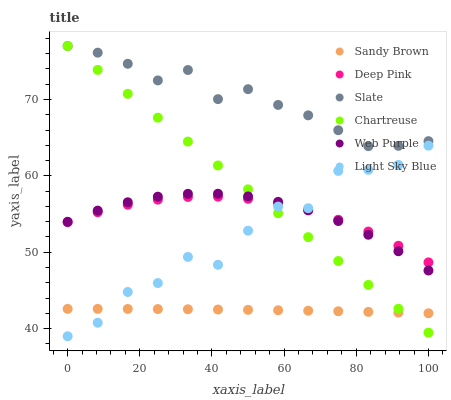Does Sandy Brown have the minimum area under the curve?
Answer yes or no. Yes. Does Slate have the maximum area under the curve?
Answer yes or no. Yes. Does Chartreuse have the minimum area under the curve?
Answer yes or no. No. Does Chartreuse have the maximum area under the curve?
Answer yes or no. No. Is Chartreuse the smoothest?
Answer yes or no. Yes. Is Light Sky Blue the roughest?
Answer yes or no. Yes. Is Slate the smoothest?
Answer yes or no. No. Is Slate the roughest?
Answer yes or no. No. Does Light Sky Blue have the lowest value?
Answer yes or no. Yes. Does Chartreuse have the lowest value?
Answer yes or no. No. Does Chartreuse have the highest value?
Answer yes or no. Yes. Does Web Purple have the highest value?
Answer yes or no. No. Is Light Sky Blue less than Slate?
Answer yes or no. Yes. Is Web Purple greater than Sandy Brown?
Answer yes or no. Yes. Does Light Sky Blue intersect Deep Pink?
Answer yes or no. Yes. Is Light Sky Blue less than Deep Pink?
Answer yes or no. No. Is Light Sky Blue greater than Deep Pink?
Answer yes or no. No. Does Light Sky Blue intersect Slate?
Answer yes or no. No. 